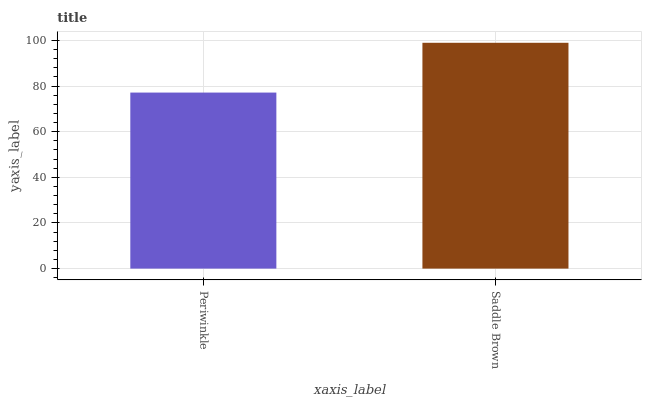Is Periwinkle the minimum?
Answer yes or no. Yes. Is Saddle Brown the maximum?
Answer yes or no. Yes. Is Saddle Brown the minimum?
Answer yes or no. No. Is Saddle Brown greater than Periwinkle?
Answer yes or no. Yes. Is Periwinkle less than Saddle Brown?
Answer yes or no. Yes. Is Periwinkle greater than Saddle Brown?
Answer yes or no. No. Is Saddle Brown less than Periwinkle?
Answer yes or no. No. Is Saddle Brown the high median?
Answer yes or no. Yes. Is Periwinkle the low median?
Answer yes or no. Yes. Is Periwinkle the high median?
Answer yes or no. No. Is Saddle Brown the low median?
Answer yes or no. No. 